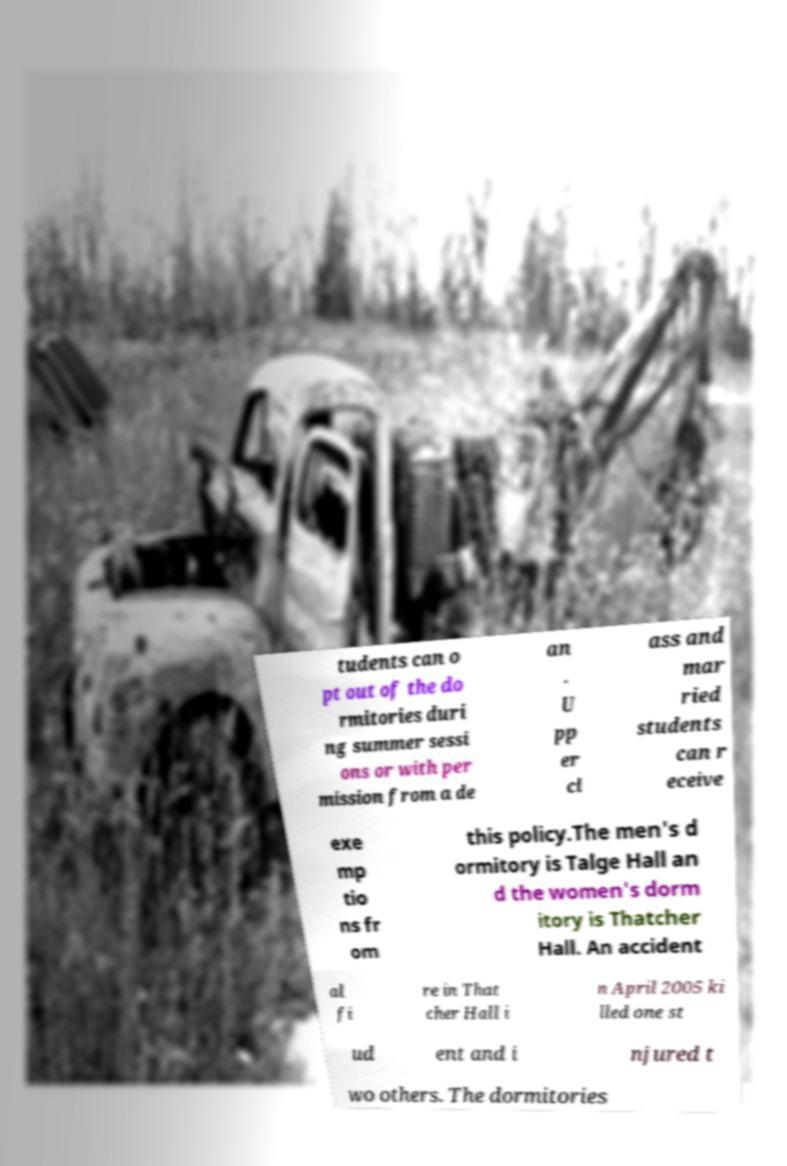Please identify and transcribe the text found in this image. tudents can o pt out of the do rmitories duri ng summer sessi ons or with per mission from a de an . U pp er cl ass and mar ried students can r eceive exe mp tio ns fr om this policy.The men's d ormitory is Talge Hall an d the women's dorm itory is Thatcher Hall. An accident al fi re in That cher Hall i n April 2005 ki lled one st ud ent and i njured t wo others. The dormitories 